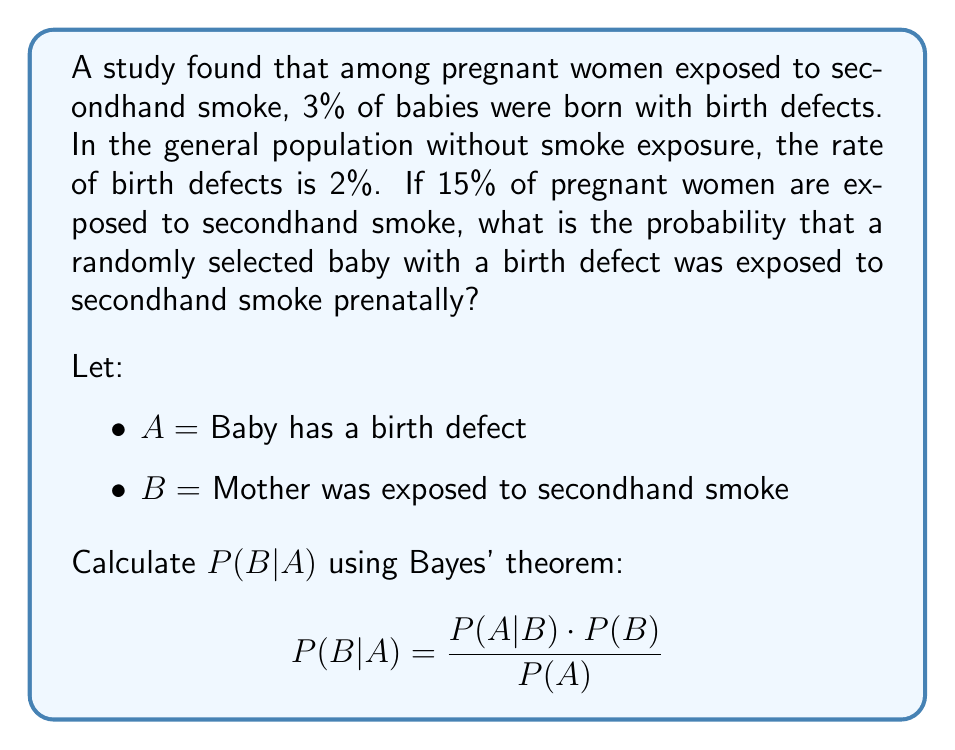Teach me how to tackle this problem. To solve this problem using Bayes' theorem, we need to follow these steps:

1. Identify the given probabilities:
   P(A|B) = 0.03 (probability of birth defect given exposure to secondhand smoke)
   P(A|not B) = 0.02 (probability of birth defect without exposure)
   P(B) = 0.15 (probability of exposure to secondhand smoke)

2. Calculate P(not B):
   P(not B) = 1 - P(B) = 1 - 0.15 = 0.85

3. Calculate P(A) using the law of total probability:
   P(A) = P(A|B) · P(B) + P(A|not B) · P(not B)
   P(A) = 0.03 · 0.15 + 0.02 · 0.85
   P(A) = 0.0045 + 0.017 = 0.0215

4. Apply Bayes' theorem:
   $$ P(B|A) = \frac{P(A|B) \cdot P(B)}{P(A)} $$
   $$ P(B|A) = \frac{0.03 \cdot 0.15}{0.0215} $$
   $$ P(B|A) = \frac{0.0045}{0.0215} \approx 0.2093 $$

5. Convert to percentage:
   0.2093 · 100% ≈ 20.93%
Answer: 20.93% 